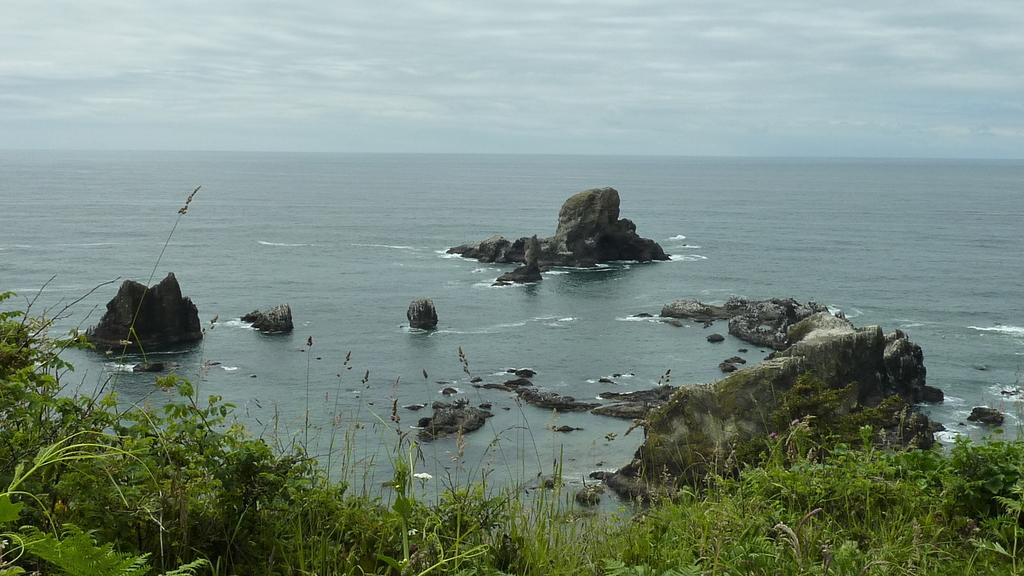What type of surface is visible in the image? There is grass on the surface in the image. What can be seen in the background of the image? There are rocks and water visible in the background of the image. What else is visible in the background of the image? The sky is visible in the background of the image. How many cherries are hanging from the scarf in the image? There are no cherries or scarf present in the image. 